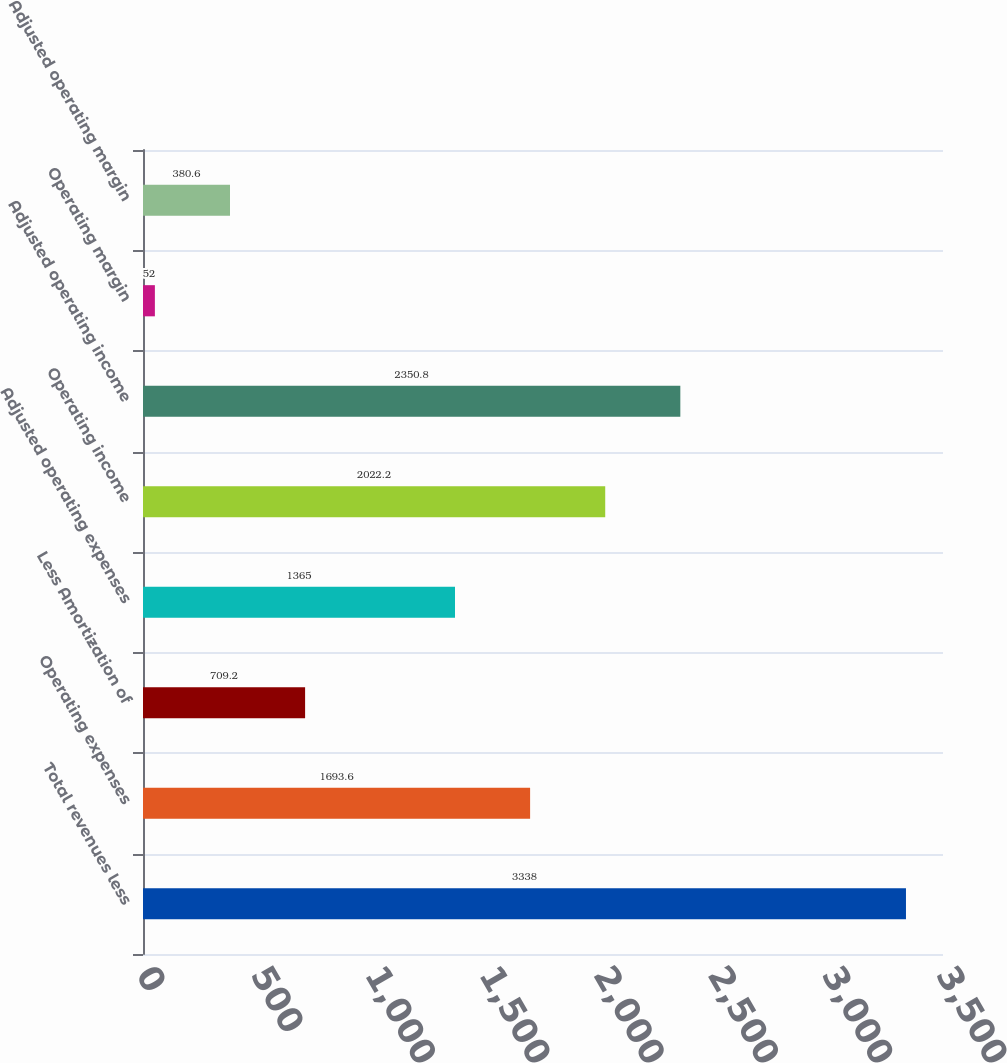Convert chart. <chart><loc_0><loc_0><loc_500><loc_500><bar_chart><fcel>Total revenues less<fcel>Operating expenses<fcel>Less Amortization of<fcel>Adjusted operating expenses<fcel>Operating income<fcel>Adjusted operating income<fcel>Operating margin<fcel>Adjusted operating margin<nl><fcel>3338<fcel>1693.6<fcel>709.2<fcel>1365<fcel>2022.2<fcel>2350.8<fcel>52<fcel>380.6<nl></chart> 